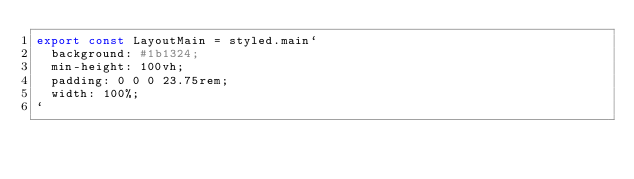Convert code to text. <code><loc_0><loc_0><loc_500><loc_500><_JavaScript_>export const LayoutMain = styled.main`
  background: #1b1324;
  min-height: 100vh;
  padding: 0 0 0 23.75rem;
  width: 100%;
`</code> 